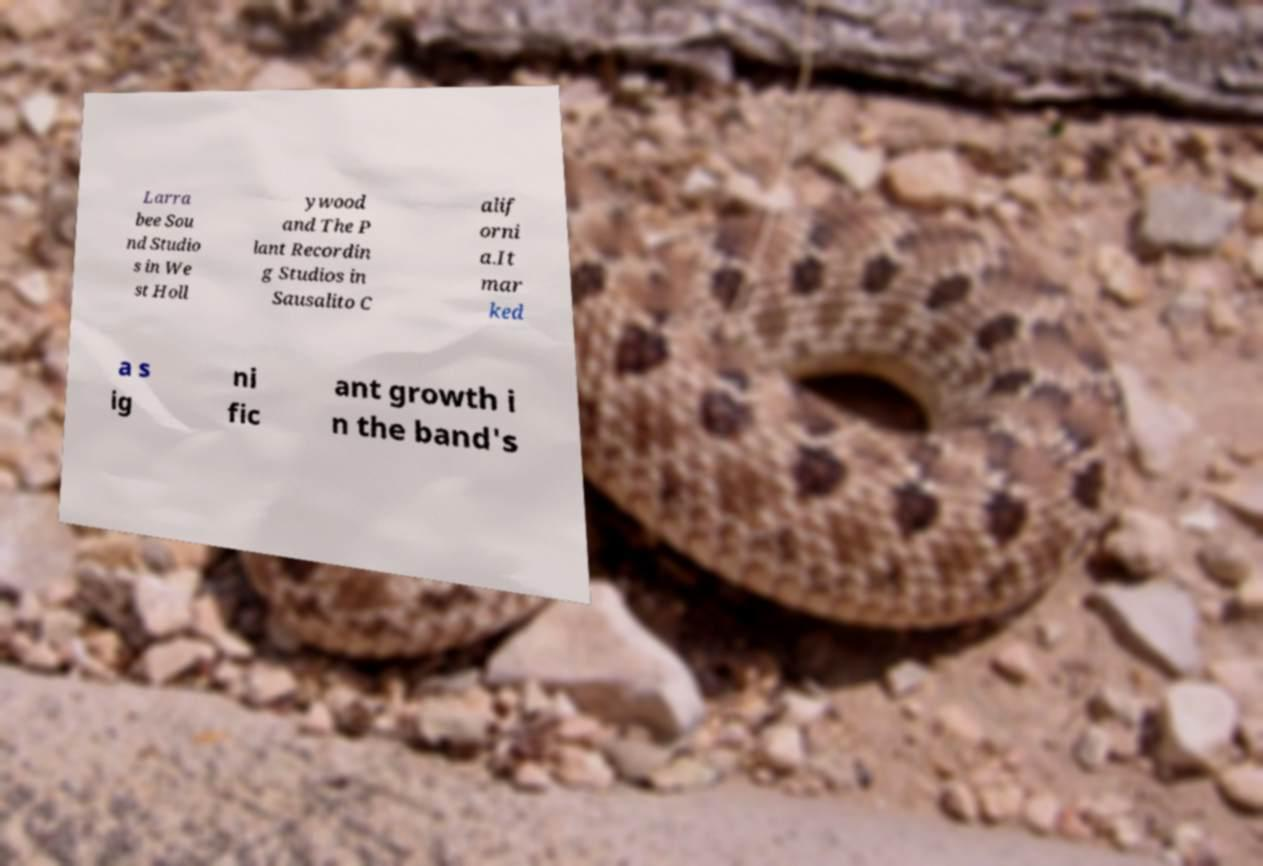Can you accurately transcribe the text from the provided image for me? Larra bee Sou nd Studio s in We st Holl ywood and The P lant Recordin g Studios in Sausalito C alif orni a.It mar ked a s ig ni fic ant growth i n the band's 